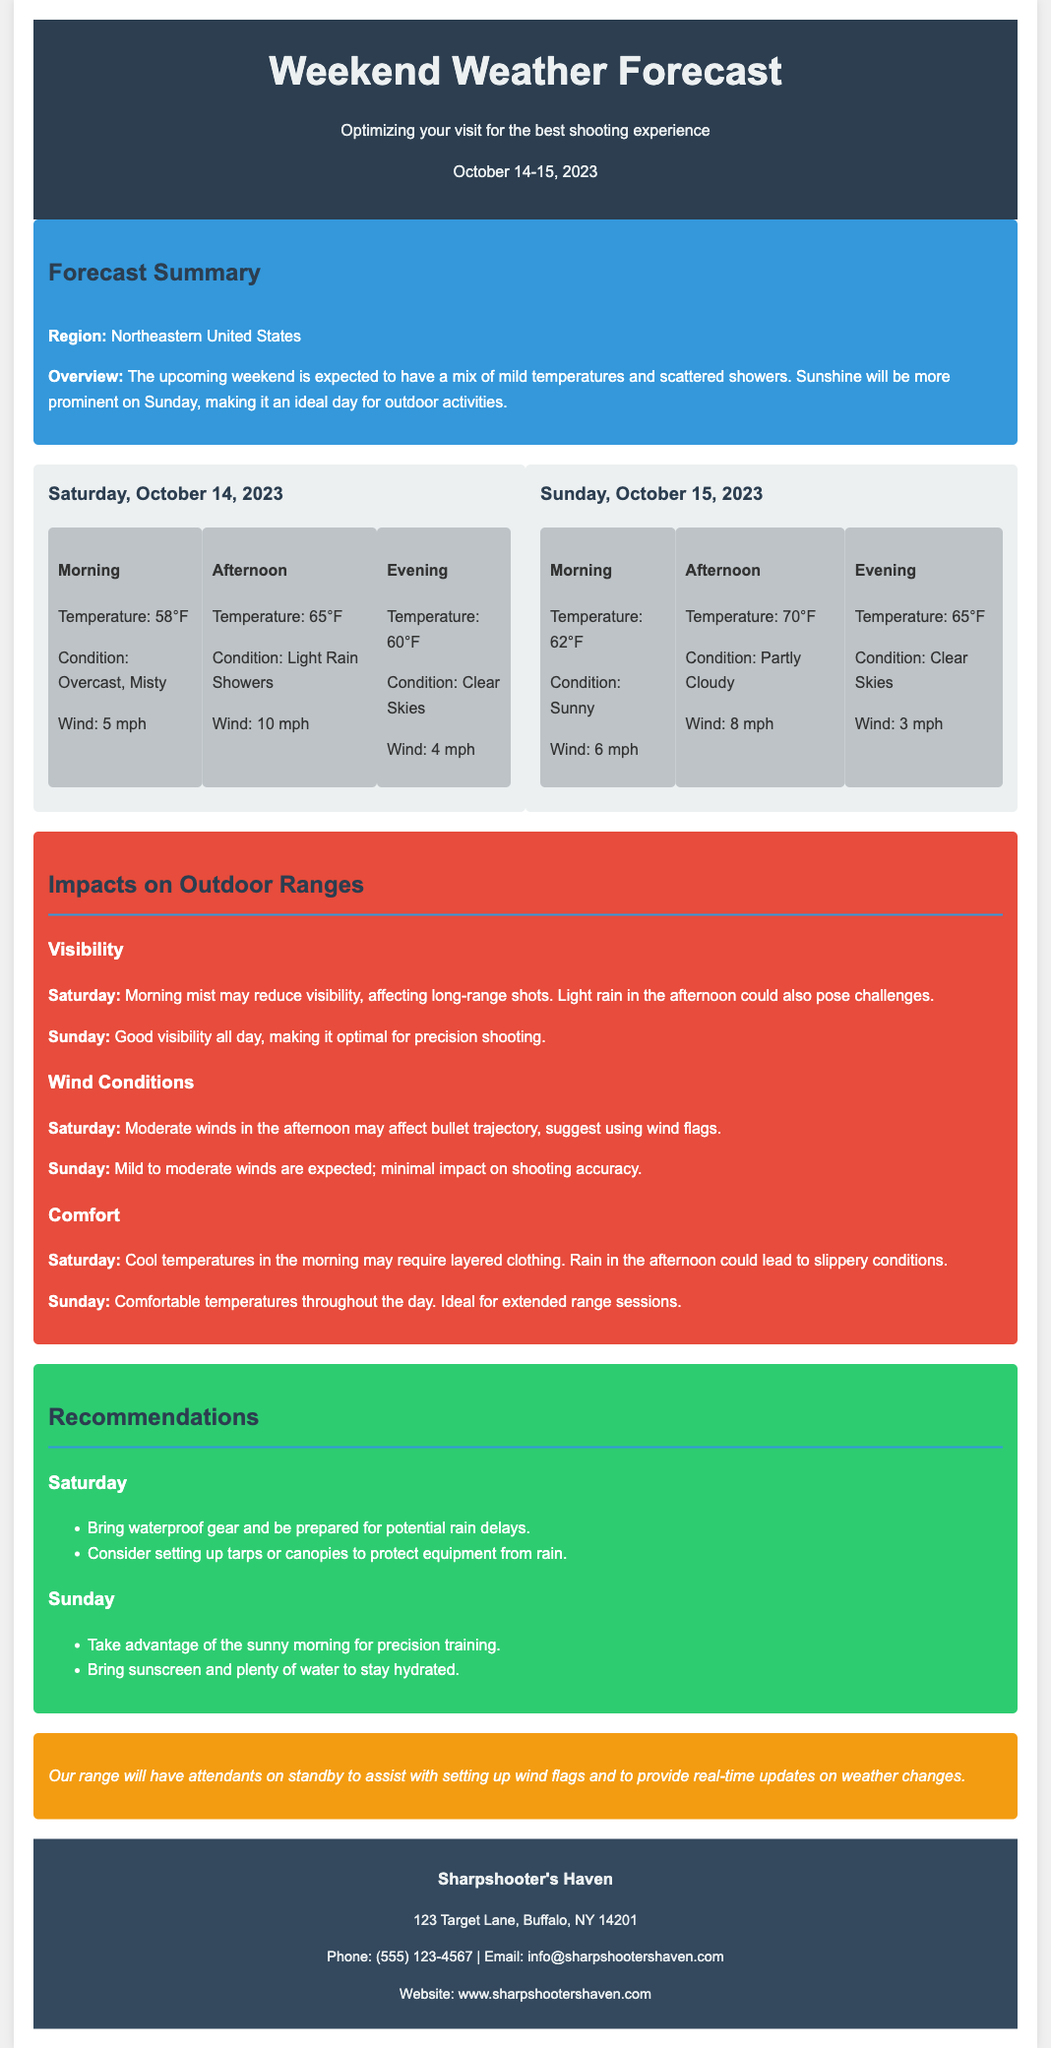What is the temperature on Saturday morning? The temperature on Saturday morning is mentioned in the daily forecast section of the document.
Answer: 58°F What weather condition is expected on Saturday afternoon? The weather condition for Saturday afternoon is provided in the daily forecast details.
Answer: Light Rain Showers What is the expected wind speed on Sunday evening? The wind speed for Sunday evening is included in the forecast details section of the document.
Answer: 3 mph What impacts visibility on Saturday? The document explains that morning mist may reduce visibility on Saturday.
Answer: Morning mist What is recommended for Saturday shooting? The recommendations section advises bringing waterproof gear due to potential rain delays on Saturday.
Answer: Waterproof gear Which day is ideal for precision shooting? The impacts section suggests that Sunday has good visibility all day, making it optimal for precision shooting.
Answer: Sunday What type of temperature is expected on Sunday? The forecast summary describes the temperatures for Sunday as comfortable throughout the day.
Answer: Comfortable What service will the range provide during the weekend? The additional note in the document states that attendants will assist with wind flags and weather updates.
Answer: Attendants on standby 